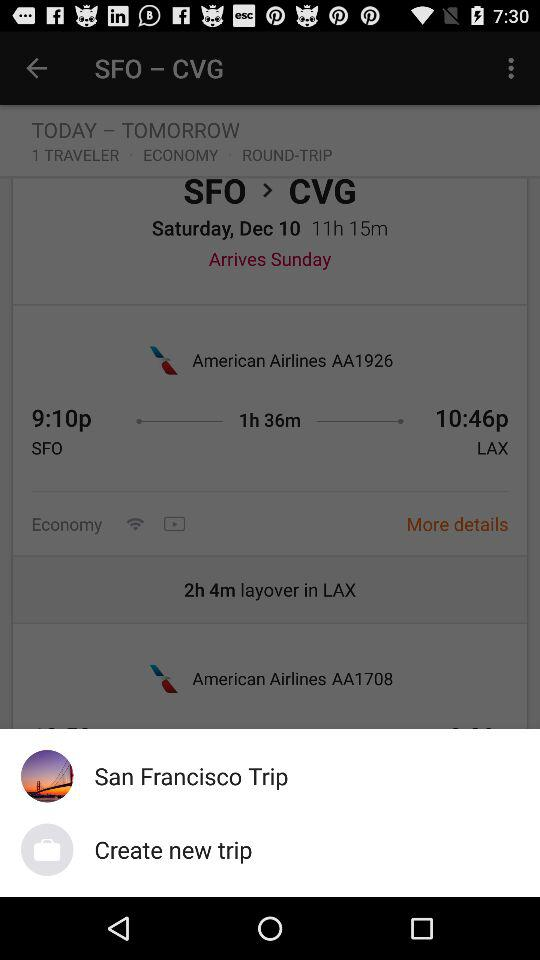How much is the round-trip ticket?
When the provided information is insufficient, respond with <no answer>. <no answer> 